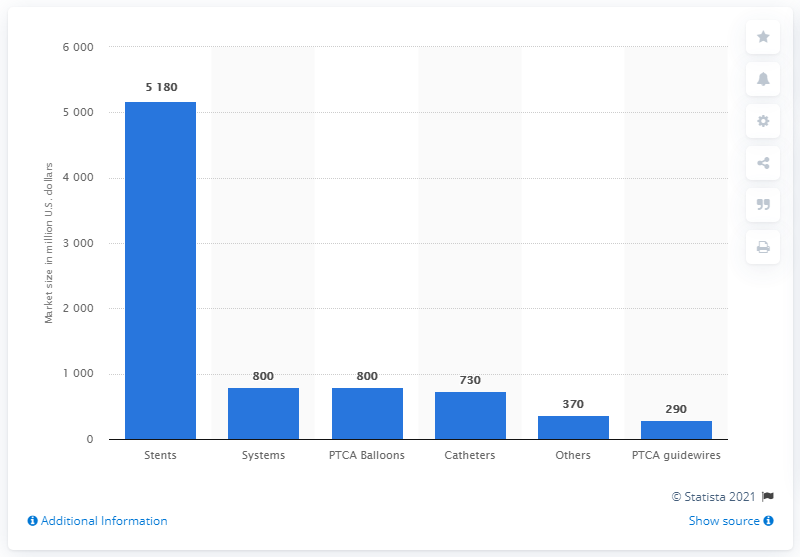Draw attention to some important aspects in this diagram. The PTCA balloons market generated approximately 800 million USD in revenue in 2013. 